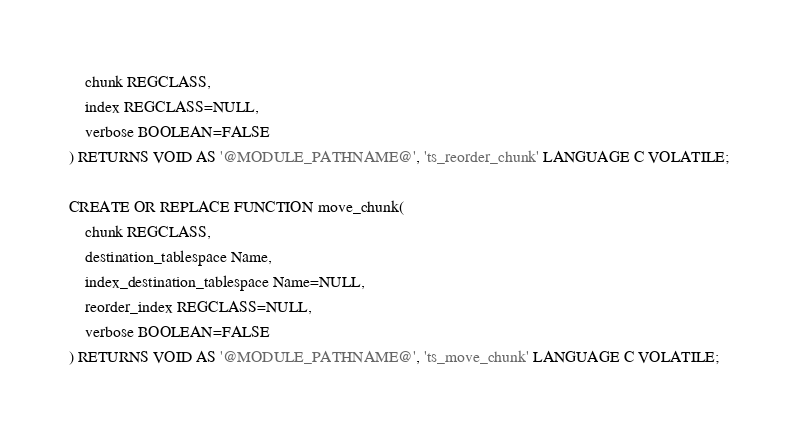Convert code to text. <code><loc_0><loc_0><loc_500><loc_500><_SQL_>    chunk REGCLASS,
    index REGCLASS=NULL,
    verbose BOOLEAN=FALSE
) RETURNS VOID AS '@MODULE_PATHNAME@', 'ts_reorder_chunk' LANGUAGE C VOLATILE;

CREATE OR REPLACE FUNCTION move_chunk(
    chunk REGCLASS,
    destination_tablespace Name,
    index_destination_tablespace Name=NULL,
    reorder_index REGCLASS=NULL,
    verbose BOOLEAN=FALSE
) RETURNS VOID AS '@MODULE_PATHNAME@', 'ts_move_chunk' LANGUAGE C VOLATILE;
</code> 